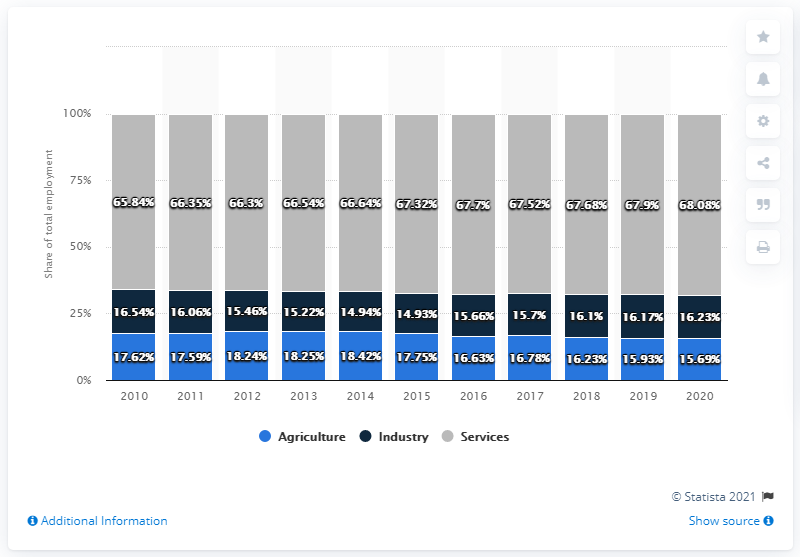List a handful of essential elements in this visual. In 2016, the industry sector comprised 15.66% of total employment in the country. The difference between the maximum agriculture share and the minimum industry share in total employment is 3.49. 